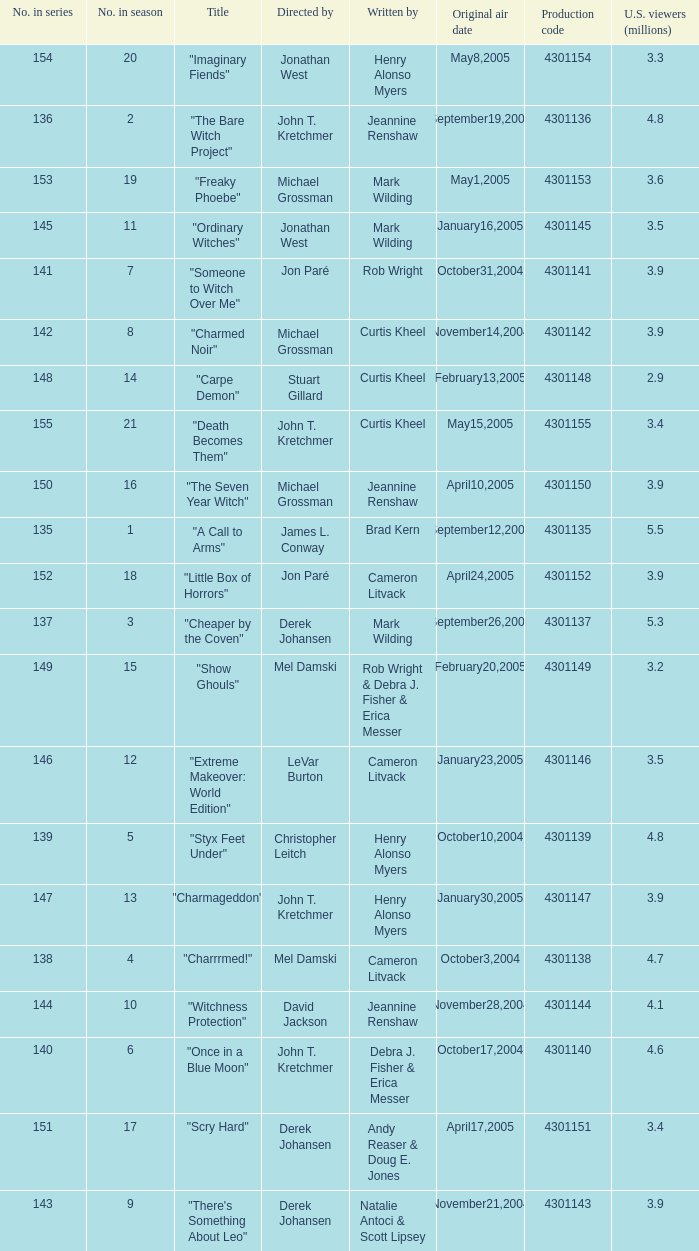When the writer is brad kern, how many u.s viewers (in millions) had the episode? 5.5. 